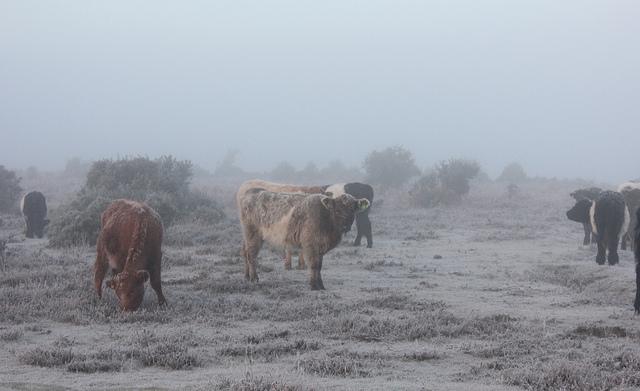What kind of terrain is this?
Give a very brief answer. Field. How many cows are eating?
Keep it brief. 2. Are there clouds out?
Quick response, please. Yes. What is the weather like?
Be succinct. Foggy. How many male cows are there in the photograph?
Be succinct. 4. Is it currently snowing?
Short answer required. Yes. Are any of the cows laying down?
Write a very short answer. No. What color is the photo?
Short answer required. White. What is the bulls doing?
Keep it brief. Grazing. Is the sky clear?
Concise answer only. No. How many cow are there?
Be succinct. 6. What are the animals called?
Quick response, please. Cows. Sunny or overcast?
Quick response, please. Overcast. 